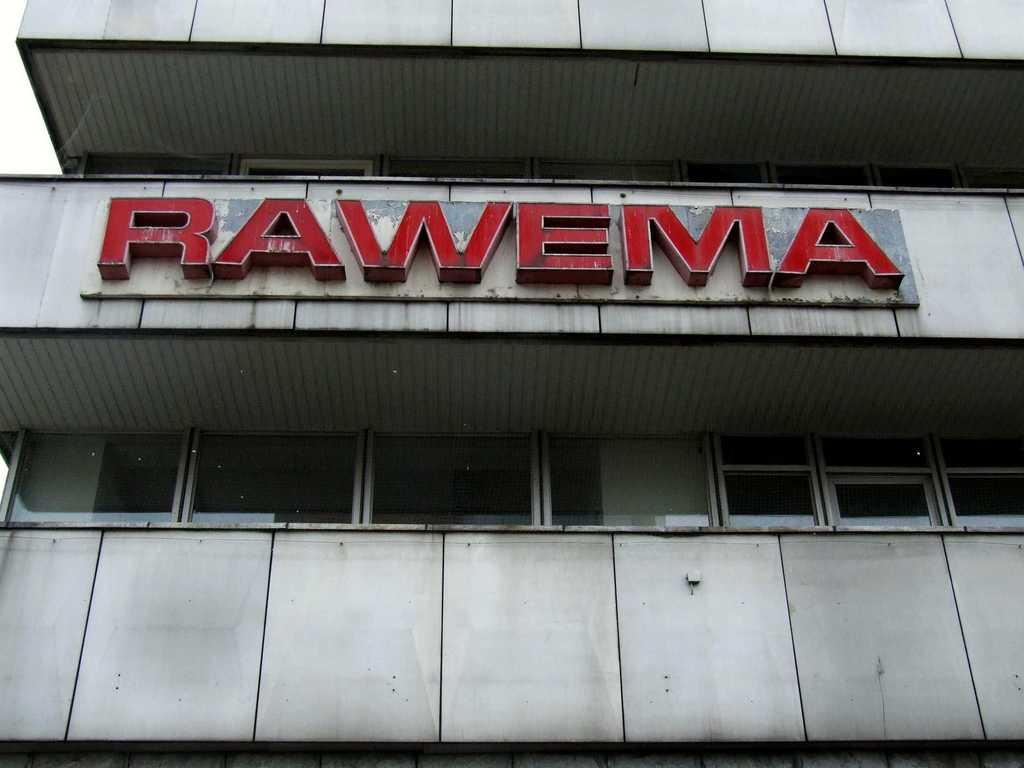What is the main structure visible in the image? There is a building in the image. What can be seen on the building? The building has text on it. What type of windows does the building have? The building has glass windows. What type of disease is    mentioned on the building in the image? There is no mention of a disease on the building in the image. 